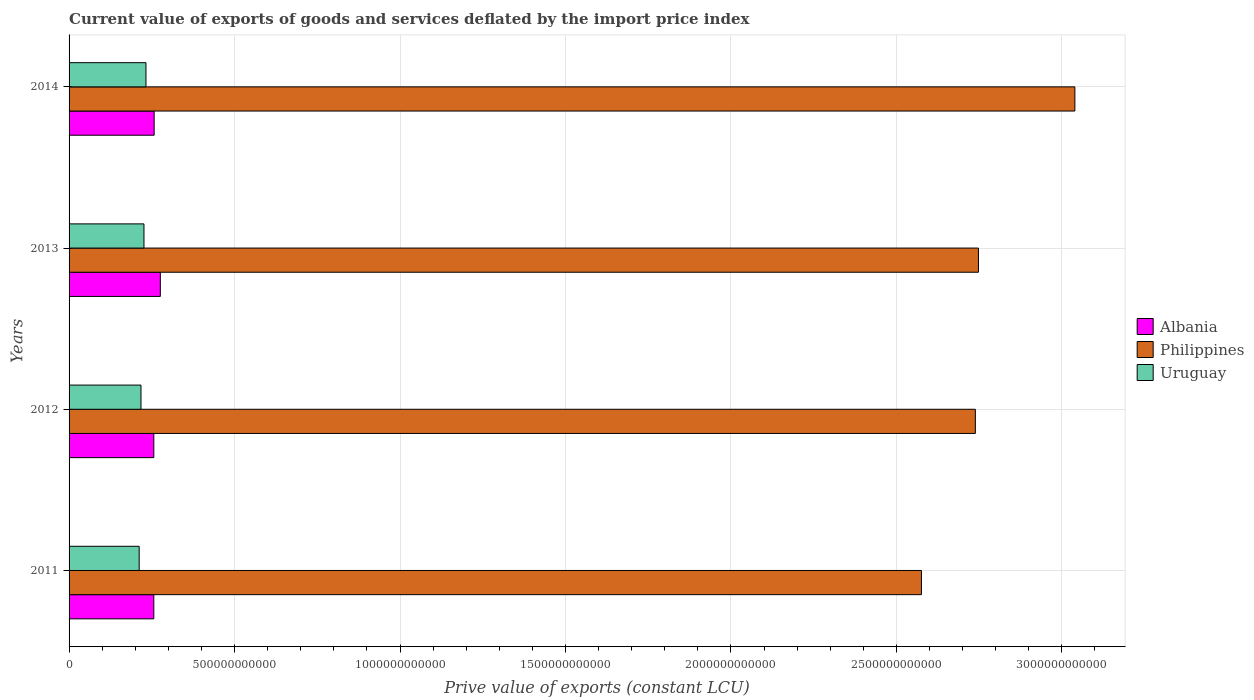How many groups of bars are there?
Make the answer very short. 4. How many bars are there on the 4th tick from the top?
Your response must be concise. 3. How many bars are there on the 2nd tick from the bottom?
Provide a short and direct response. 3. In how many cases, is the number of bars for a given year not equal to the number of legend labels?
Offer a very short reply. 0. What is the prive value of exports in Albania in 2012?
Your response must be concise. 2.56e+11. Across all years, what is the maximum prive value of exports in Uruguay?
Make the answer very short. 2.32e+11. Across all years, what is the minimum prive value of exports in Philippines?
Keep it short and to the point. 2.58e+12. In which year was the prive value of exports in Uruguay minimum?
Provide a short and direct response. 2011. What is the total prive value of exports in Albania in the graph?
Make the answer very short. 1.05e+12. What is the difference between the prive value of exports in Uruguay in 2011 and that in 2012?
Provide a short and direct response. -5.47e+09. What is the difference between the prive value of exports in Albania in 2011 and the prive value of exports in Uruguay in 2012?
Ensure brevity in your answer.  3.88e+1. What is the average prive value of exports in Albania per year?
Keep it short and to the point. 2.61e+11. In the year 2014, what is the difference between the prive value of exports in Uruguay and prive value of exports in Philippines?
Make the answer very short. -2.81e+12. What is the ratio of the prive value of exports in Albania in 2011 to that in 2013?
Your answer should be compact. 0.93. What is the difference between the highest and the second highest prive value of exports in Albania?
Your answer should be compact. 1.87e+1. What is the difference between the highest and the lowest prive value of exports in Philippines?
Your response must be concise. 4.64e+11. In how many years, is the prive value of exports in Albania greater than the average prive value of exports in Albania taken over all years?
Provide a short and direct response. 1. Is the sum of the prive value of exports in Philippines in 2011 and 2012 greater than the maximum prive value of exports in Uruguay across all years?
Your answer should be compact. Yes. What does the 2nd bar from the bottom in 2011 represents?
Ensure brevity in your answer.  Philippines. How many years are there in the graph?
Provide a succinct answer. 4. What is the difference between two consecutive major ticks on the X-axis?
Ensure brevity in your answer.  5.00e+11. Does the graph contain grids?
Your answer should be compact. Yes. What is the title of the graph?
Give a very brief answer. Current value of exports of goods and services deflated by the import price index. What is the label or title of the X-axis?
Make the answer very short. Prive value of exports (constant LCU). What is the Prive value of exports (constant LCU) of Albania in 2011?
Offer a very short reply. 2.56e+11. What is the Prive value of exports (constant LCU) in Philippines in 2011?
Keep it short and to the point. 2.58e+12. What is the Prive value of exports (constant LCU) in Uruguay in 2011?
Ensure brevity in your answer.  2.12e+11. What is the Prive value of exports (constant LCU) of Albania in 2012?
Provide a succinct answer. 2.56e+11. What is the Prive value of exports (constant LCU) in Philippines in 2012?
Offer a very short reply. 2.74e+12. What is the Prive value of exports (constant LCU) in Uruguay in 2012?
Your answer should be very brief. 2.17e+11. What is the Prive value of exports (constant LCU) of Albania in 2013?
Your answer should be very brief. 2.76e+11. What is the Prive value of exports (constant LCU) in Philippines in 2013?
Your answer should be very brief. 2.75e+12. What is the Prive value of exports (constant LCU) of Uruguay in 2013?
Offer a very short reply. 2.26e+11. What is the Prive value of exports (constant LCU) in Albania in 2014?
Provide a succinct answer. 2.57e+11. What is the Prive value of exports (constant LCU) of Philippines in 2014?
Make the answer very short. 3.04e+12. What is the Prive value of exports (constant LCU) of Uruguay in 2014?
Your answer should be very brief. 2.32e+11. Across all years, what is the maximum Prive value of exports (constant LCU) in Albania?
Your answer should be very brief. 2.76e+11. Across all years, what is the maximum Prive value of exports (constant LCU) of Philippines?
Give a very brief answer. 3.04e+12. Across all years, what is the maximum Prive value of exports (constant LCU) in Uruguay?
Offer a terse response. 2.32e+11. Across all years, what is the minimum Prive value of exports (constant LCU) in Albania?
Give a very brief answer. 2.56e+11. Across all years, what is the minimum Prive value of exports (constant LCU) in Philippines?
Offer a very short reply. 2.58e+12. Across all years, what is the minimum Prive value of exports (constant LCU) of Uruguay?
Make the answer very short. 2.12e+11. What is the total Prive value of exports (constant LCU) in Albania in the graph?
Make the answer very short. 1.05e+12. What is the total Prive value of exports (constant LCU) of Philippines in the graph?
Offer a terse response. 1.11e+13. What is the total Prive value of exports (constant LCU) in Uruguay in the graph?
Offer a terse response. 8.88e+11. What is the difference between the Prive value of exports (constant LCU) in Albania in 2011 and that in 2012?
Offer a terse response. 2.18e+07. What is the difference between the Prive value of exports (constant LCU) of Philippines in 2011 and that in 2012?
Ensure brevity in your answer.  -1.63e+11. What is the difference between the Prive value of exports (constant LCU) of Uruguay in 2011 and that in 2012?
Your answer should be very brief. -5.47e+09. What is the difference between the Prive value of exports (constant LCU) of Albania in 2011 and that in 2013?
Your response must be concise. -1.97e+1. What is the difference between the Prive value of exports (constant LCU) in Philippines in 2011 and that in 2013?
Ensure brevity in your answer.  -1.72e+11. What is the difference between the Prive value of exports (constant LCU) in Uruguay in 2011 and that in 2013?
Give a very brief answer. -1.45e+1. What is the difference between the Prive value of exports (constant LCU) of Albania in 2011 and that in 2014?
Offer a very short reply. -1.02e+09. What is the difference between the Prive value of exports (constant LCU) of Philippines in 2011 and that in 2014?
Offer a terse response. -4.64e+11. What is the difference between the Prive value of exports (constant LCU) of Uruguay in 2011 and that in 2014?
Ensure brevity in your answer.  -2.06e+1. What is the difference between the Prive value of exports (constant LCU) in Albania in 2012 and that in 2013?
Ensure brevity in your answer.  -1.97e+1. What is the difference between the Prive value of exports (constant LCU) in Philippines in 2012 and that in 2013?
Provide a succinct answer. -9.36e+09. What is the difference between the Prive value of exports (constant LCU) of Uruguay in 2012 and that in 2013?
Ensure brevity in your answer.  -9.01e+09. What is the difference between the Prive value of exports (constant LCU) in Albania in 2012 and that in 2014?
Offer a terse response. -1.04e+09. What is the difference between the Prive value of exports (constant LCU) of Philippines in 2012 and that in 2014?
Your answer should be very brief. -3.01e+11. What is the difference between the Prive value of exports (constant LCU) of Uruguay in 2012 and that in 2014?
Your answer should be compact. -1.51e+1. What is the difference between the Prive value of exports (constant LCU) in Albania in 2013 and that in 2014?
Ensure brevity in your answer.  1.87e+1. What is the difference between the Prive value of exports (constant LCU) in Philippines in 2013 and that in 2014?
Provide a short and direct response. -2.91e+11. What is the difference between the Prive value of exports (constant LCU) of Uruguay in 2013 and that in 2014?
Your answer should be very brief. -6.07e+09. What is the difference between the Prive value of exports (constant LCU) of Albania in 2011 and the Prive value of exports (constant LCU) of Philippines in 2012?
Offer a terse response. -2.48e+12. What is the difference between the Prive value of exports (constant LCU) in Albania in 2011 and the Prive value of exports (constant LCU) in Uruguay in 2012?
Offer a terse response. 3.88e+1. What is the difference between the Prive value of exports (constant LCU) of Philippines in 2011 and the Prive value of exports (constant LCU) of Uruguay in 2012?
Your answer should be very brief. 2.36e+12. What is the difference between the Prive value of exports (constant LCU) in Albania in 2011 and the Prive value of exports (constant LCU) in Philippines in 2013?
Make the answer very short. -2.49e+12. What is the difference between the Prive value of exports (constant LCU) of Albania in 2011 and the Prive value of exports (constant LCU) of Uruguay in 2013?
Make the answer very short. 2.98e+1. What is the difference between the Prive value of exports (constant LCU) in Philippines in 2011 and the Prive value of exports (constant LCU) in Uruguay in 2013?
Ensure brevity in your answer.  2.35e+12. What is the difference between the Prive value of exports (constant LCU) of Albania in 2011 and the Prive value of exports (constant LCU) of Philippines in 2014?
Offer a terse response. -2.78e+12. What is the difference between the Prive value of exports (constant LCU) of Albania in 2011 and the Prive value of exports (constant LCU) of Uruguay in 2014?
Keep it short and to the point. 2.37e+1. What is the difference between the Prive value of exports (constant LCU) of Philippines in 2011 and the Prive value of exports (constant LCU) of Uruguay in 2014?
Keep it short and to the point. 2.34e+12. What is the difference between the Prive value of exports (constant LCU) in Albania in 2012 and the Prive value of exports (constant LCU) in Philippines in 2013?
Your response must be concise. -2.49e+12. What is the difference between the Prive value of exports (constant LCU) of Albania in 2012 and the Prive value of exports (constant LCU) of Uruguay in 2013?
Offer a very short reply. 2.97e+1. What is the difference between the Prive value of exports (constant LCU) in Philippines in 2012 and the Prive value of exports (constant LCU) in Uruguay in 2013?
Your response must be concise. 2.51e+12. What is the difference between the Prive value of exports (constant LCU) of Albania in 2012 and the Prive value of exports (constant LCU) of Philippines in 2014?
Your answer should be compact. -2.78e+12. What is the difference between the Prive value of exports (constant LCU) of Albania in 2012 and the Prive value of exports (constant LCU) of Uruguay in 2014?
Provide a short and direct response. 2.37e+1. What is the difference between the Prive value of exports (constant LCU) of Philippines in 2012 and the Prive value of exports (constant LCU) of Uruguay in 2014?
Provide a succinct answer. 2.51e+12. What is the difference between the Prive value of exports (constant LCU) of Albania in 2013 and the Prive value of exports (constant LCU) of Philippines in 2014?
Provide a succinct answer. -2.76e+12. What is the difference between the Prive value of exports (constant LCU) of Albania in 2013 and the Prive value of exports (constant LCU) of Uruguay in 2014?
Give a very brief answer. 4.34e+1. What is the difference between the Prive value of exports (constant LCU) of Philippines in 2013 and the Prive value of exports (constant LCU) of Uruguay in 2014?
Offer a very short reply. 2.52e+12. What is the average Prive value of exports (constant LCU) in Albania per year?
Keep it short and to the point. 2.61e+11. What is the average Prive value of exports (constant LCU) of Philippines per year?
Your answer should be very brief. 2.78e+12. What is the average Prive value of exports (constant LCU) of Uruguay per year?
Provide a short and direct response. 2.22e+11. In the year 2011, what is the difference between the Prive value of exports (constant LCU) in Albania and Prive value of exports (constant LCU) in Philippines?
Your response must be concise. -2.32e+12. In the year 2011, what is the difference between the Prive value of exports (constant LCU) in Albania and Prive value of exports (constant LCU) in Uruguay?
Provide a succinct answer. 4.42e+1. In the year 2011, what is the difference between the Prive value of exports (constant LCU) of Philippines and Prive value of exports (constant LCU) of Uruguay?
Your answer should be very brief. 2.36e+12. In the year 2012, what is the difference between the Prive value of exports (constant LCU) in Albania and Prive value of exports (constant LCU) in Philippines?
Make the answer very short. -2.48e+12. In the year 2012, what is the difference between the Prive value of exports (constant LCU) in Albania and Prive value of exports (constant LCU) in Uruguay?
Your answer should be very brief. 3.87e+1. In the year 2012, what is the difference between the Prive value of exports (constant LCU) of Philippines and Prive value of exports (constant LCU) of Uruguay?
Provide a succinct answer. 2.52e+12. In the year 2013, what is the difference between the Prive value of exports (constant LCU) of Albania and Prive value of exports (constant LCU) of Philippines?
Your answer should be compact. -2.47e+12. In the year 2013, what is the difference between the Prive value of exports (constant LCU) in Albania and Prive value of exports (constant LCU) in Uruguay?
Offer a very short reply. 4.95e+1. In the year 2013, what is the difference between the Prive value of exports (constant LCU) in Philippines and Prive value of exports (constant LCU) in Uruguay?
Provide a short and direct response. 2.52e+12. In the year 2014, what is the difference between the Prive value of exports (constant LCU) in Albania and Prive value of exports (constant LCU) in Philippines?
Your answer should be very brief. -2.78e+12. In the year 2014, what is the difference between the Prive value of exports (constant LCU) in Albania and Prive value of exports (constant LCU) in Uruguay?
Provide a short and direct response. 2.47e+1. In the year 2014, what is the difference between the Prive value of exports (constant LCU) of Philippines and Prive value of exports (constant LCU) of Uruguay?
Provide a succinct answer. 2.81e+12. What is the ratio of the Prive value of exports (constant LCU) of Philippines in 2011 to that in 2012?
Ensure brevity in your answer.  0.94. What is the ratio of the Prive value of exports (constant LCU) in Uruguay in 2011 to that in 2012?
Offer a terse response. 0.97. What is the ratio of the Prive value of exports (constant LCU) of Albania in 2011 to that in 2013?
Your response must be concise. 0.93. What is the ratio of the Prive value of exports (constant LCU) of Philippines in 2011 to that in 2013?
Your answer should be very brief. 0.94. What is the ratio of the Prive value of exports (constant LCU) in Uruguay in 2011 to that in 2013?
Give a very brief answer. 0.94. What is the ratio of the Prive value of exports (constant LCU) in Philippines in 2011 to that in 2014?
Your response must be concise. 0.85. What is the ratio of the Prive value of exports (constant LCU) in Uruguay in 2011 to that in 2014?
Provide a short and direct response. 0.91. What is the ratio of the Prive value of exports (constant LCU) in Albania in 2012 to that in 2013?
Your response must be concise. 0.93. What is the ratio of the Prive value of exports (constant LCU) in Uruguay in 2012 to that in 2013?
Give a very brief answer. 0.96. What is the ratio of the Prive value of exports (constant LCU) of Philippines in 2012 to that in 2014?
Your answer should be very brief. 0.9. What is the ratio of the Prive value of exports (constant LCU) in Uruguay in 2012 to that in 2014?
Offer a very short reply. 0.94. What is the ratio of the Prive value of exports (constant LCU) in Albania in 2013 to that in 2014?
Your answer should be very brief. 1.07. What is the ratio of the Prive value of exports (constant LCU) of Philippines in 2013 to that in 2014?
Your answer should be very brief. 0.9. What is the ratio of the Prive value of exports (constant LCU) in Uruguay in 2013 to that in 2014?
Keep it short and to the point. 0.97. What is the difference between the highest and the second highest Prive value of exports (constant LCU) of Albania?
Give a very brief answer. 1.87e+1. What is the difference between the highest and the second highest Prive value of exports (constant LCU) of Philippines?
Provide a short and direct response. 2.91e+11. What is the difference between the highest and the second highest Prive value of exports (constant LCU) in Uruguay?
Ensure brevity in your answer.  6.07e+09. What is the difference between the highest and the lowest Prive value of exports (constant LCU) of Albania?
Offer a terse response. 1.97e+1. What is the difference between the highest and the lowest Prive value of exports (constant LCU) of Philippines?
Your response must be concise. 4.64e+11. What is the difference between the highest and the lowest Prive value of exports (constant LCU) of Uruguay?
Make the answer very short. 2.06e+1. 